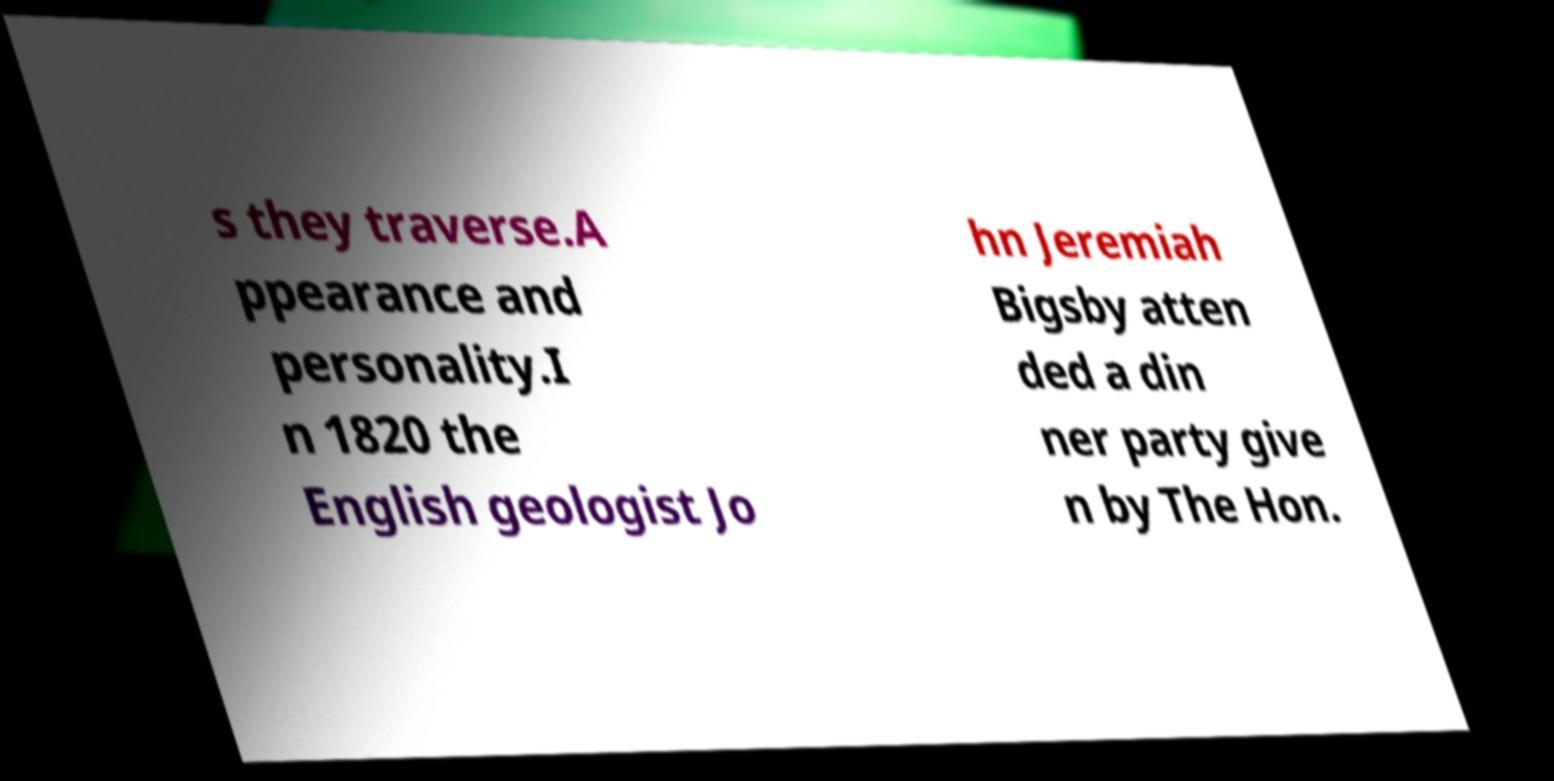What messages or text are displayed in this image? I need them in a readable, typed format. s they traverse.A ppearance and personality.I n 1820 the English geologist Jo hn Jeremiah Bigsby atten ded a din ner party give n by The Hon. 